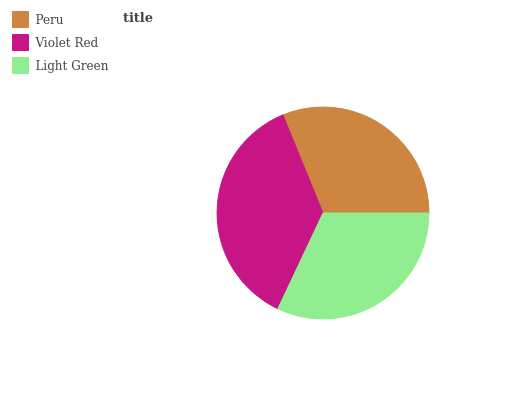Is Peru the minimum?
Answer yes or no. Yes. Is Violet Red the maximum?
Answer yes or no. Yes. Is Light Green the minimum?
Answer yes or no. No. Is Light Green the maximum?
Answer yes or no. No. Is Violet Red greater than Light Green?
Answer yes or no. Yes. Is Light Green less than Violet Red?
Answer yes or no. Yes. Is Light Green greater than Violet Red?
Answer yes or no. No. Is Violet Red less than Light Green?
Answer yes or no. No. Is Light Green the high median?
Answer yes or no. Yes. Is Light Green the low median?
Answer yes or no. Yes. Is Violet Red the high median?
Answer yes or no. No. Is Peru the low median?
Answer yes or no. No. 